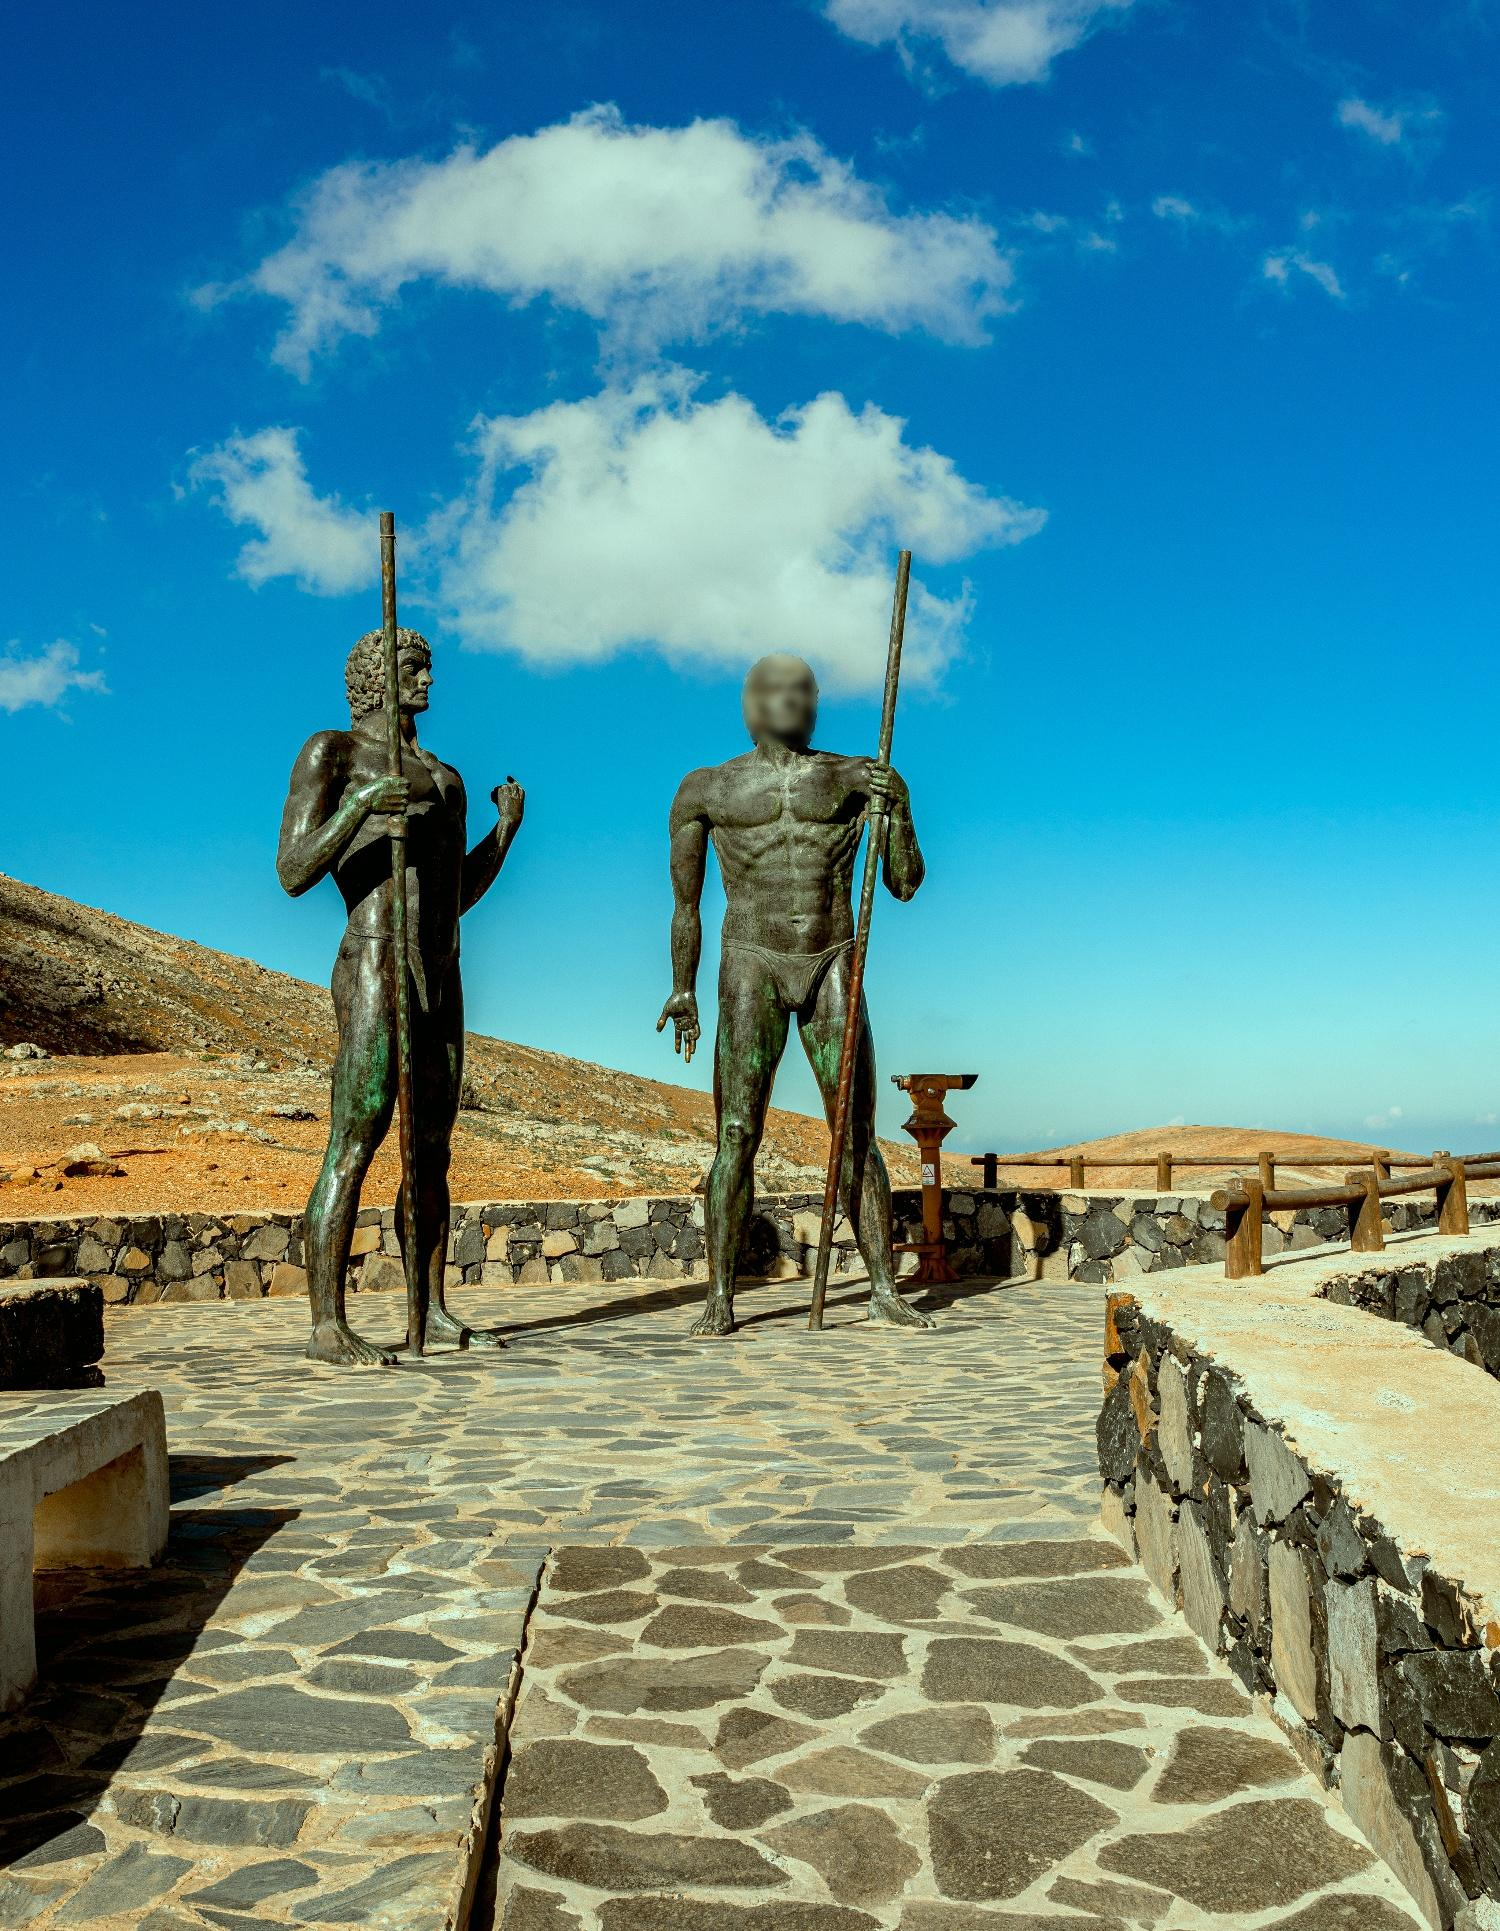Can you tell me more about the artistic style of these statues? The statues are sculpted in a realistic style, characterized by detailed muscular definition and dynamic poses that convey a sense of movement and strength. The realistic depiction of the facial features and the textures on the statues' surfaces, such as the hair and skin, reflect skilled craftsmanship and classical influences, likely inspired by ancient Greek or Roman art. 